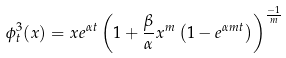<formula> <loc_0><loc_0><loc_500><loc_500>\phi _ { t } ^ { 3 } ( x ) = x e ^ { \alpha t } \left ( 1 + \frac { \beta } { \alpha } x ^ { m } \left ( 1 - e ^ { \alpha m t } \right ) \right ) ^ { \frac { - 1 } { m } }</formula> 